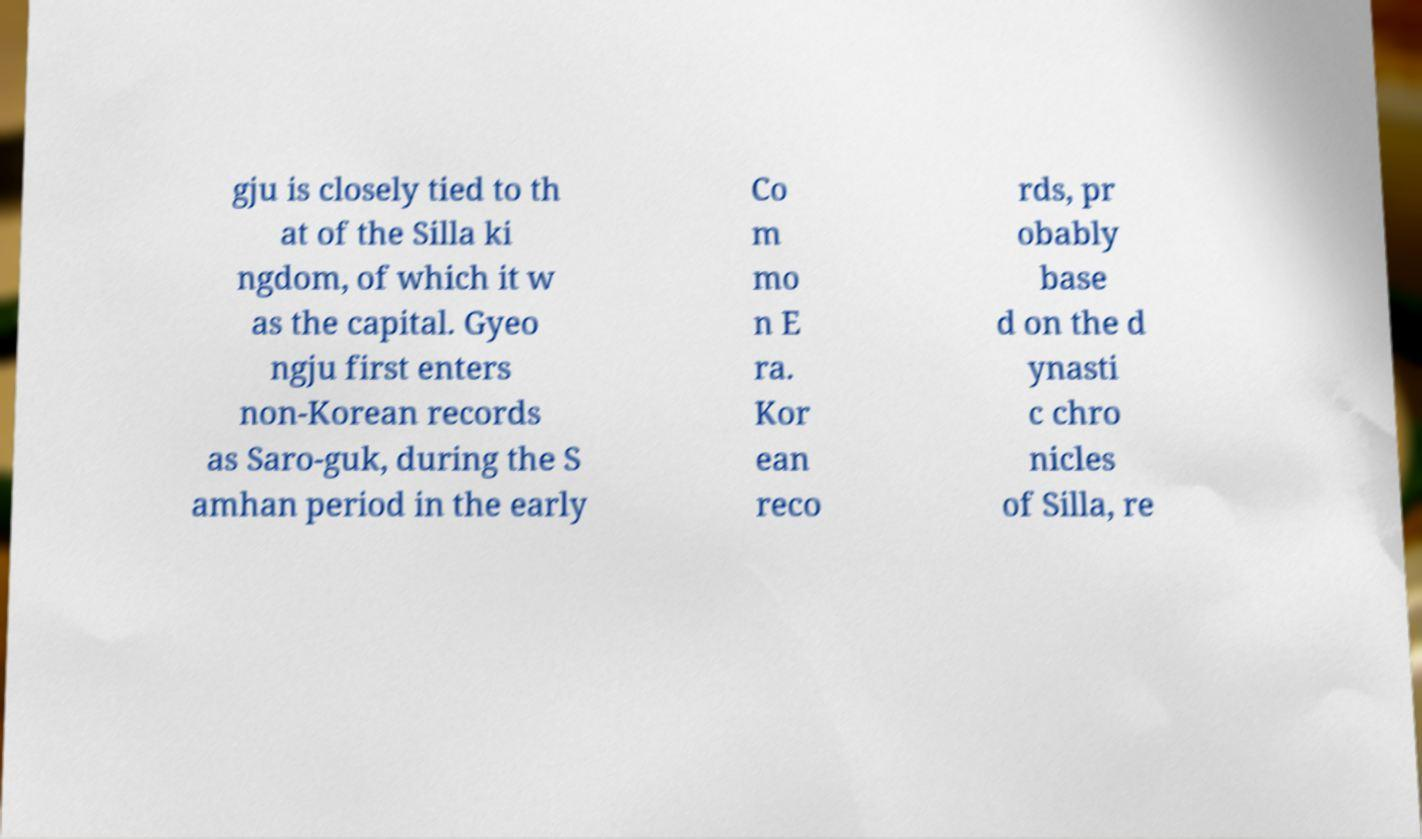I need the written content from this picture converted into text. Can you do that? gju is closely tied to th at of the Silla ki ngdom, of which it w as the capital. Gyeo ngju first enters non-Korean records as Saro-guk, during the S amhan period in the early Co m mo n E ra. Kor ean reco rds, pr obably base d on the d ynasti c chro nicles of Silla, re 